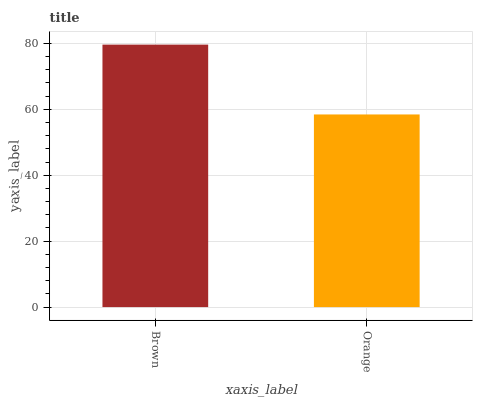Is Orange the minimum?
Answer yes or no. Yes. Is Brown the maximum?
Answer yes or no. Yes. Is Orange the maximum?
Answer yes or no. No. Is Brown greater than Orange?
Answer yes or no. Yes. Is Orange less than Brown?
Answer yes or no. Yes. Is Orange greater than Brown?
Answer yes or no. No. Is Brown less than Orange?
Answer yes or no. No. Is Brown the high median?
Answer yes or no. Yes. Is Orange the low median?
Answer yes or no. Yes. Is Orange the high median?
Answer yes or no. No. Is Brown the low median?
Answer yes or no. No. 